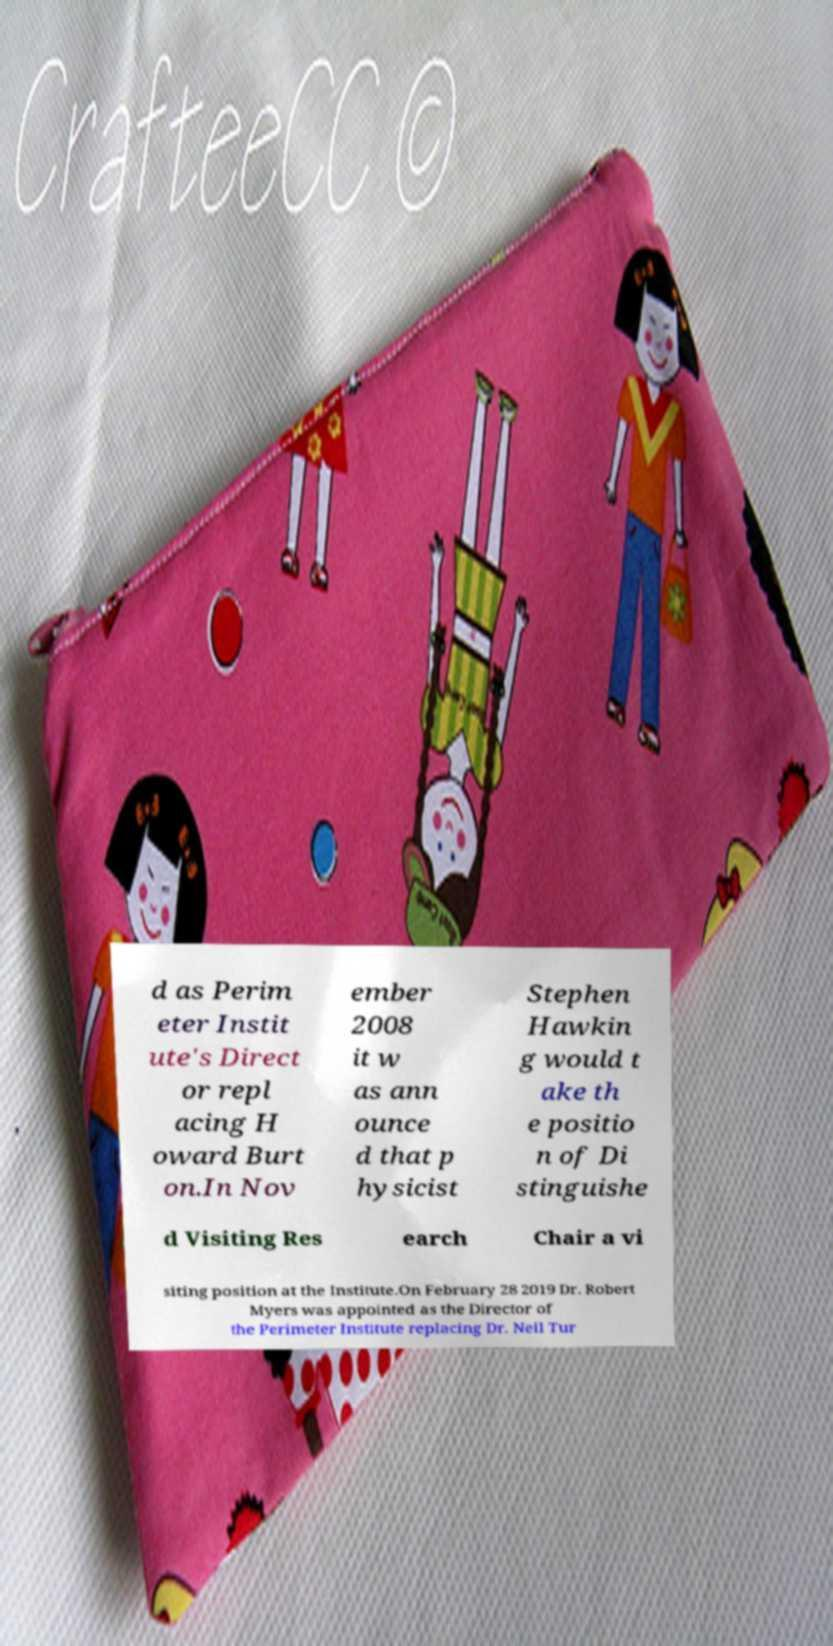I need the written content from this picture converted into text. Can you do that? d as Perim eter Instit ute's Direct or repl acing H oward Burt on.In Nov ember 2008 it w as ann ounce d that p hysicist Stephen Hawkin g would t ake th e positio n of Di stinguishe d Visiting Res earch Chair a vi siting position at the Institute.On February 28 2019 Dr. Robert Myers was appointed as the Director of the Perimeter Institute replacing Dr. Neil Tur 